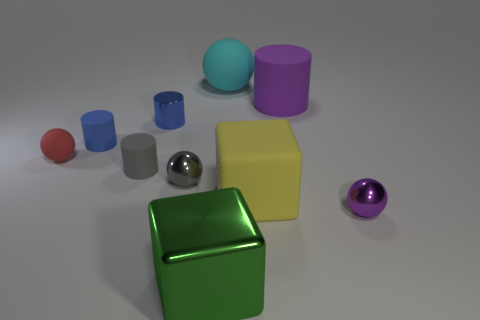Subtract all big rubber balls. How many balls are left? 3 Subtract all green spheres. How many blue cylinders are left? 2 Subtract all blue cylinders. How many cylinders are left? 2 Subtract all blocks. How many objects are left? 8 Subtract 1 blocks. How many blocks are left? 1 Subtract all purple cylinders. Subtract all red spheres. How many cylinders are left? 3 Subtract all tiny purple shiny things. Subtract all cylinders. How many objects are left? 5 Add 8 blue metal cylinders. How many blue metal cylinders are left? 9 Add 6 brown matte spheres. How many brown matte spheres exist? 6 Subtract 1 green cubes. How many objects are left? 9 